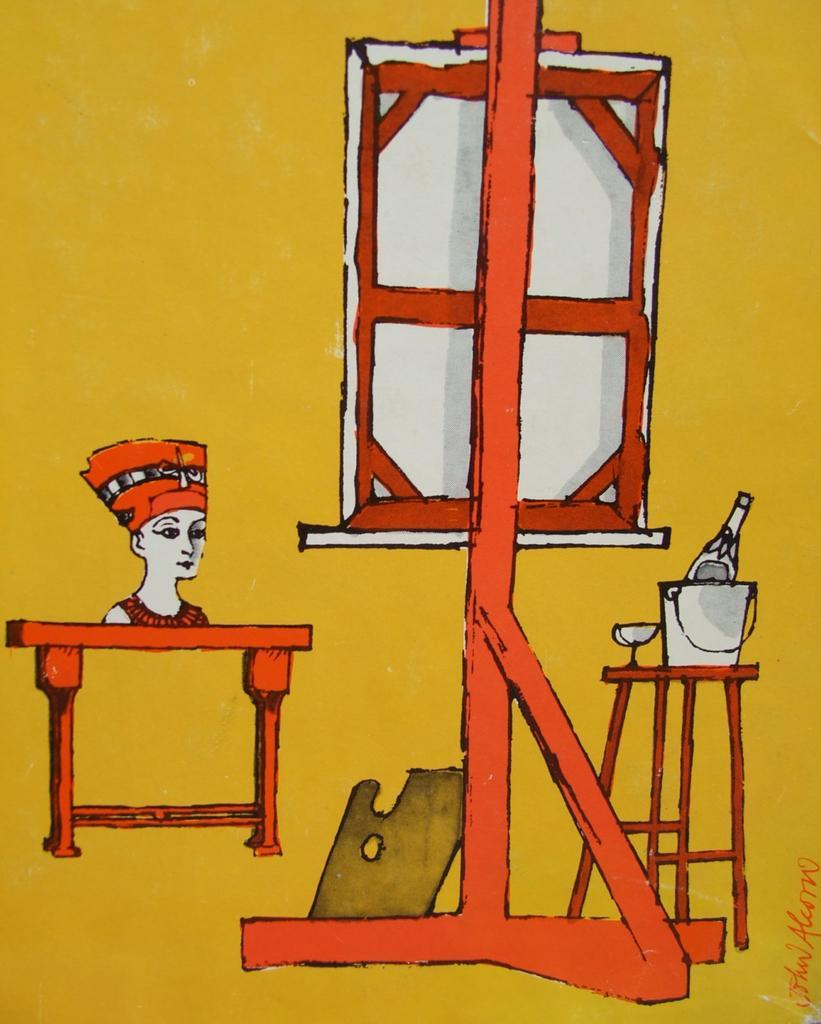Describe this image in one or two sentences. This image consists of an art of a few images. In this image the background is dark. On the right side of the image there is a bucket, a bottle and a glass on the stool. There is a board and there is a sculpture. 